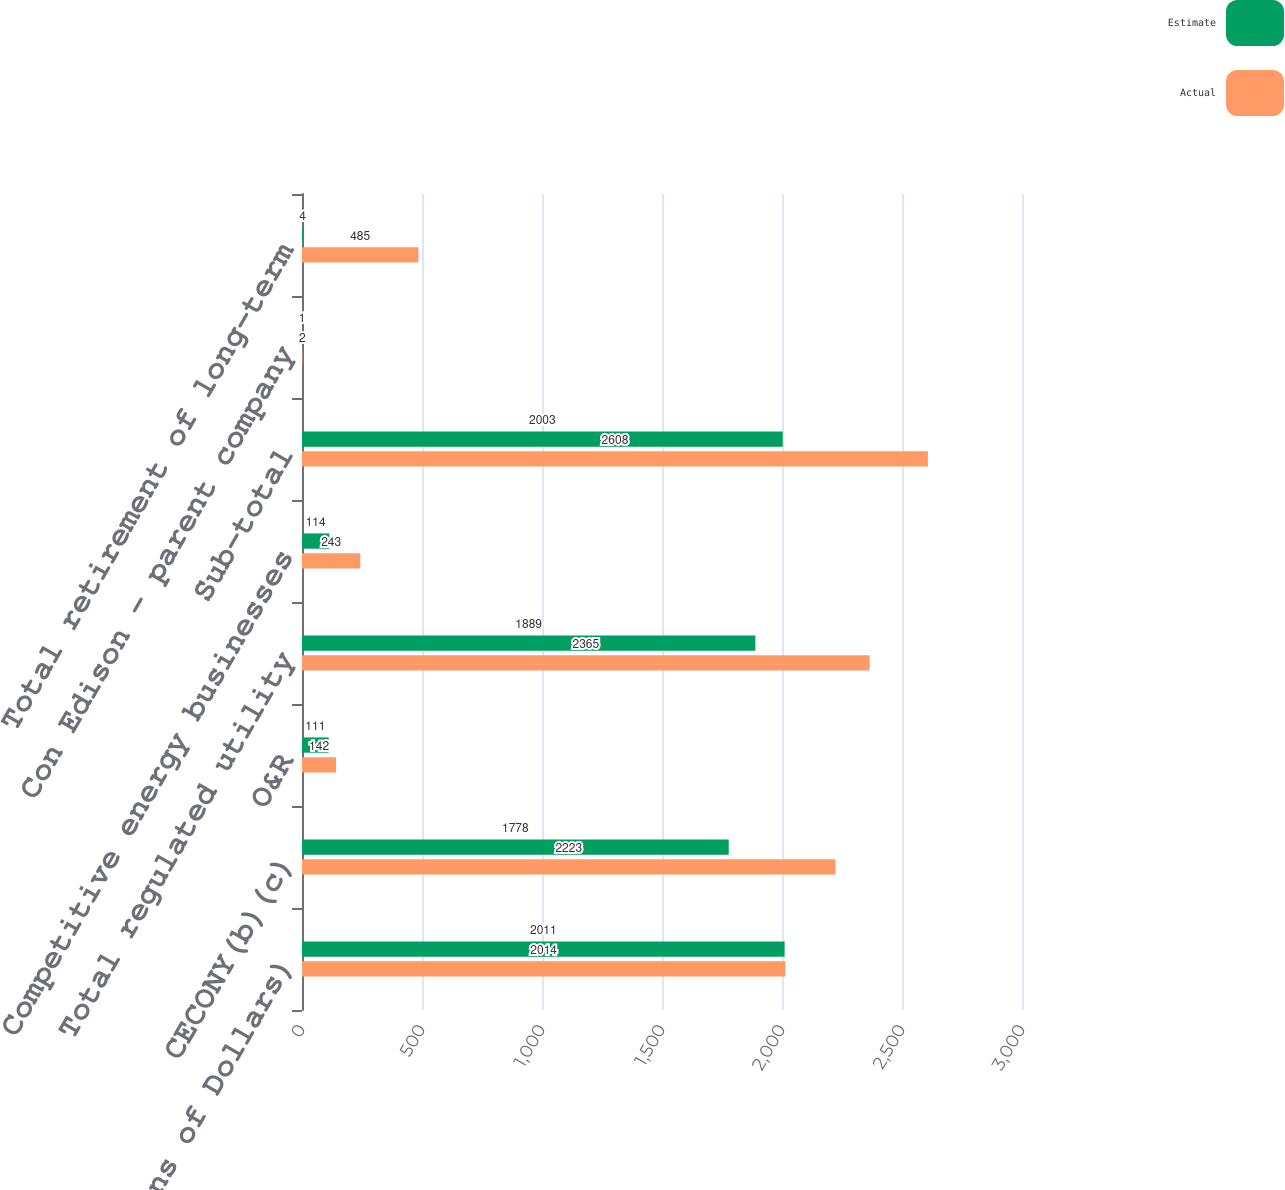Convert chart to OTSL. <chart><loc_0><loc_0><loc_500><loc_500><stacked_bar_chart><ecel><fcel>(Millions of Dollars)<fcel>CECONY(b)(c)<fcel>O&R<fcel>Total regulated utility<fcel>Competitive energy businesses<fcel>Sub-total<fcel>Con Edison - parent company<fcel>Total retirement of long-term<nl><fcel>Estimate<fcel>2011<fcel>1778<fcel>111<fcel>1889<fcel>114<fcel>2003<fcel>1<fcel>4<nl><fcel>Actual<fcel>2014<fcel>2223<fcel>142<fcel>2365<fcel>243<fcel>2608<fcel>2<fcel>485<nl></chart> 